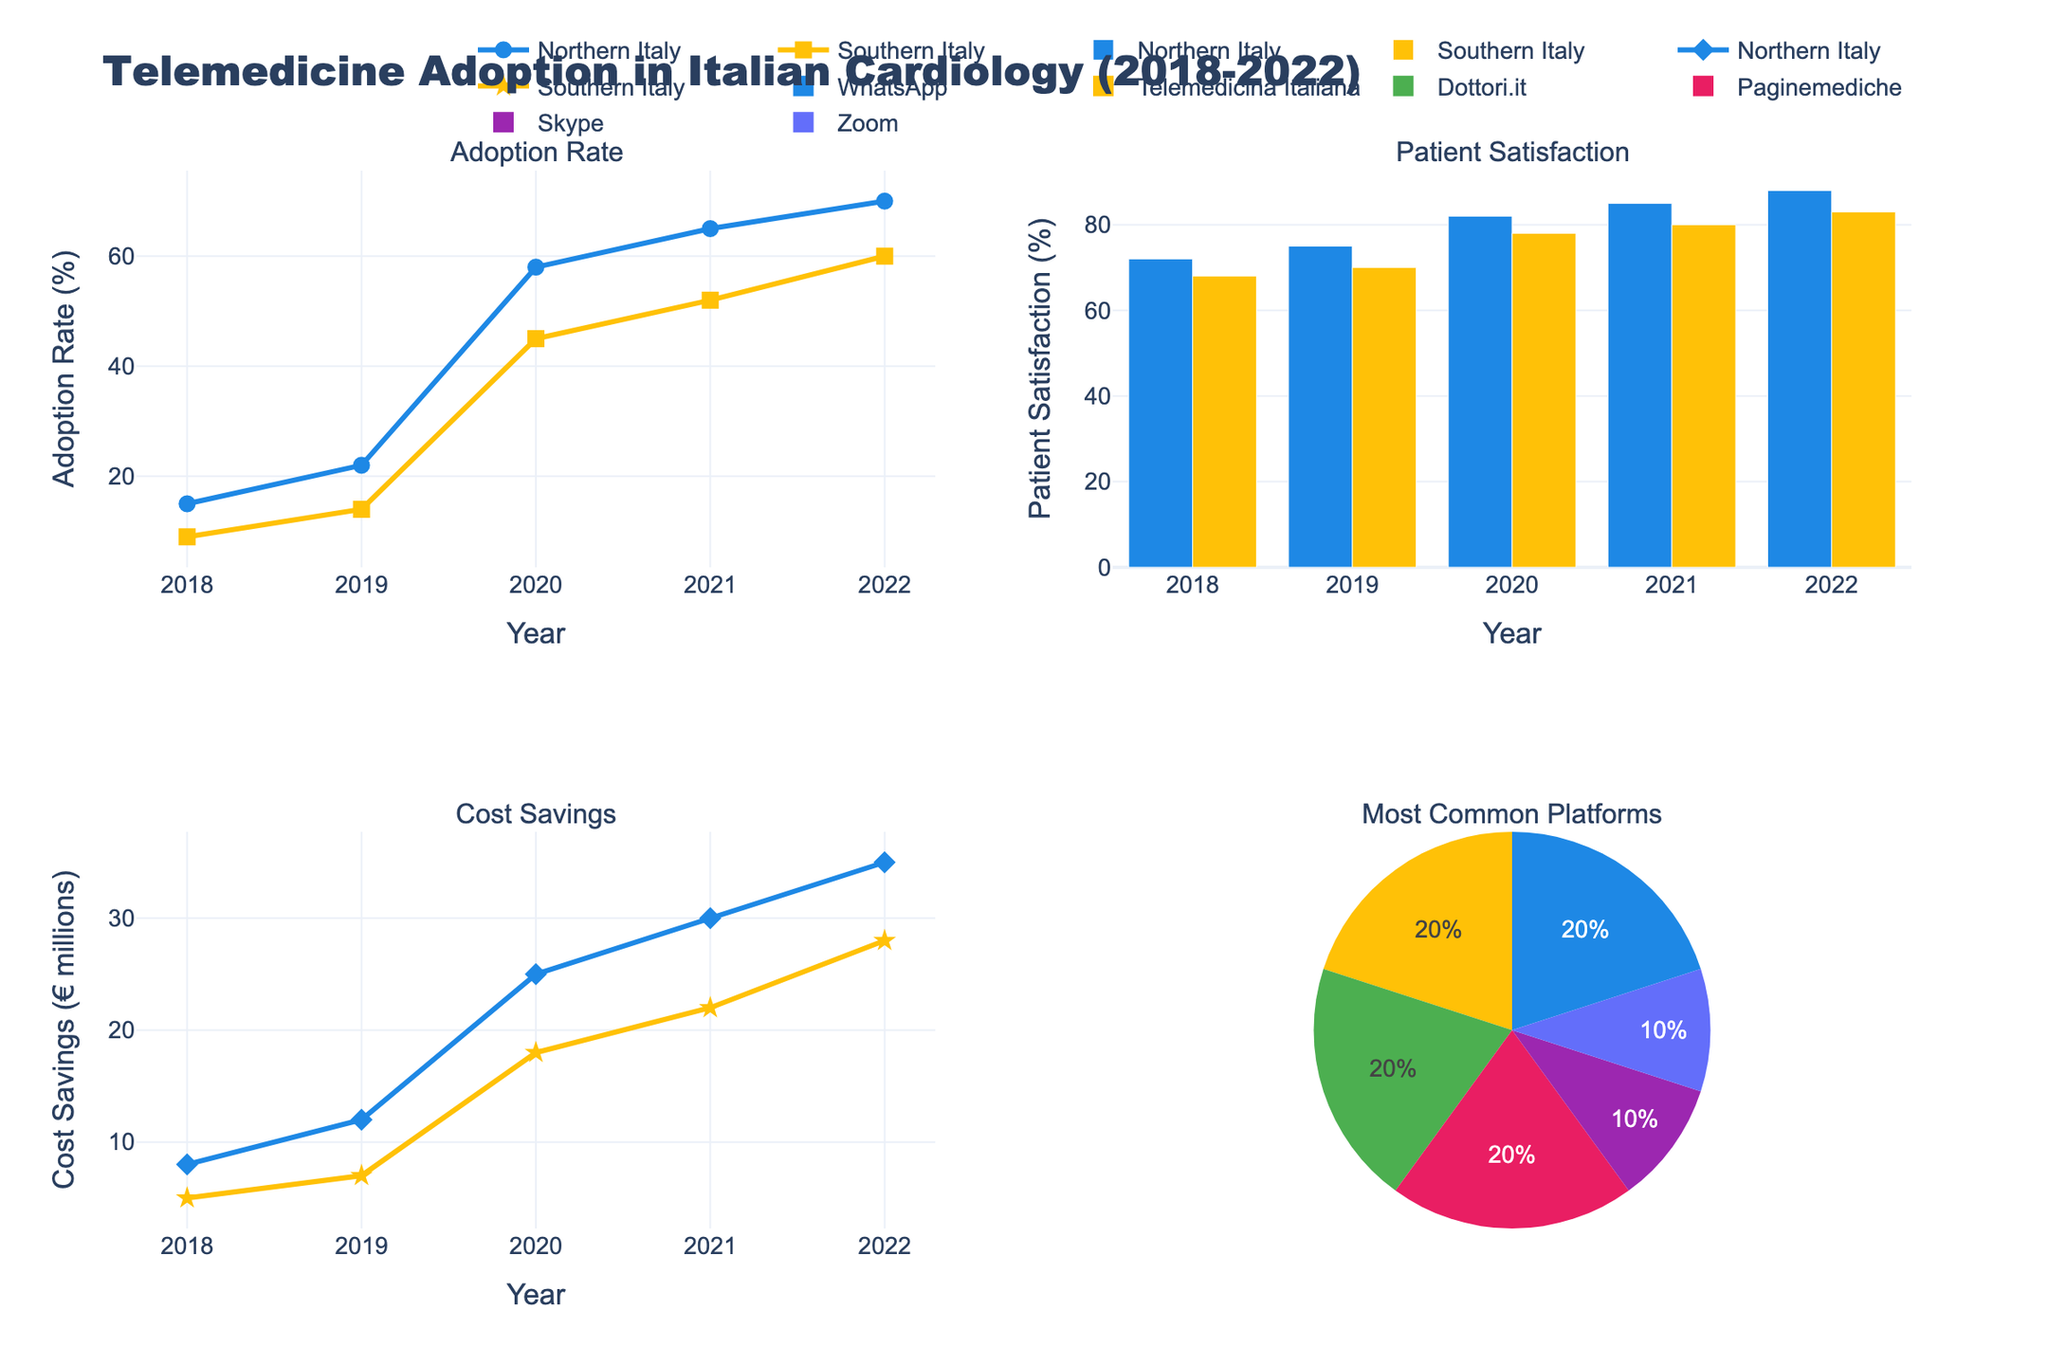How did the adoption rates for telemedicine in Northern and Southern Italy compare in 2020? In 2020, the Northern Italy adoption rate is about 58% and for Southern Italy it is 45%. This can be directly seen from the line and marker plot for the adoption rates.
Answer: Northern Italy had higher adoption rates (58%) than Southern Italy (45%) Which year has the highest patient satisfaction rate in Northern Italy and what was the rate? The bar plot for patient satisfaction shows that Northern Italy had the highest rate in 2022, at 88%.
Answer: 2022, 88% In which year did Southern Italy see a sharp increase in telemedicine adoption rates compared to the previous year? Observing the line and markers for Southern Italy, there is a notable increase in adoption rate from 2019 to 2020, where it rises from 14% to 45%.
Answer: 2020 Which region consistently had higher cost savings from telemedicine over the years, and by how much in 2022? The scatter plots for cost savings show Northern Italy maintaining higher cost savings each year. In 2022, Northern Italy saved €35 million, while Southern Italy saved €28 million, so the difference is €7 million.
Answer: Northern Italy, €7 million Which platform was the most commonly used for telemedicine across all years in Italy? The pie chart shows all platforms used, with Paginemediche having the largest portion, suggesting it was the most commonly used.
Answer: Paginemediche Based on the trend from 2018 to 2022, which region improved patient satisfaction more significantly? Comparing the bar plots, Northern Italy’s patient satisfaction improved from 72% in 2018 to 88% in 2022 (16% increase), while Southern Italy’s increased from 68% to 83% (15% increase). Therefore, Northern Italy had a slightly more significant improvement.
Answer: Northern Italy How did the cost savings progress for Southern Italy from 2019 to 2020 and from 2020 to 2021? The scatter plot shows Southern Italy's cost savings increased from €7 million in 2019 to €18 million in 2020, a rise of €11 million, and from €18 million in 2020 to €22 million in 2021, a rise of €4 million.
Answer: €11 million, €4 million What was the adoption rate trend for both regions from 2018 to 2022? Observing both lines in the adoption rate subplot, both Northern and Southern Italy show a steady increase over the years, with Northern Italy consistently having higher rates. Northern Italy goes from 15% in 2018 to 70% in 2022, while Southern rises from 9% to 60%.
Answer: Both regions increased steadily Which year saw the highest cost savings in Northern Italy, and what was the amount? The scatter plot for cost savings highlights 2022 as the year with the highest savings for Northern Italy, amounting to €35 million.
Answer: 2022, €35 million 